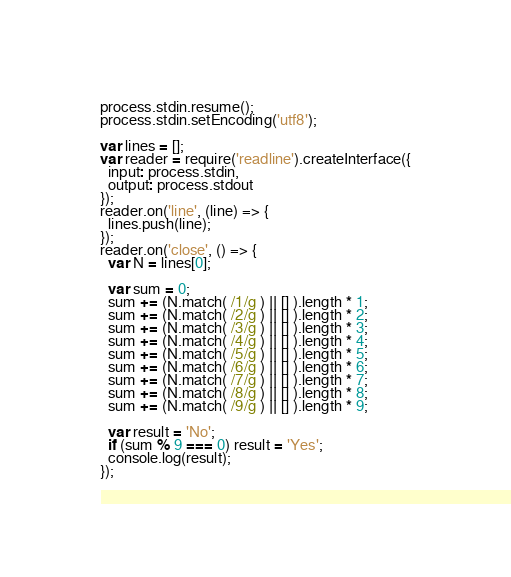<code> <loc_0><loc_0><loc_500><loc_500><_JavaScript_>process.stdin.resume();
process.stdin.setEncoding('utf8');

var lines = [];
var reader = require('readline').createInterface({
  input: process.stdin,
  output: process.stdout
});
reader.on('line', (line) => {
  lines.push(line);
});
reader.on('close', () => {
  var N = lines[0];

  var sum = 0;
  sum += (N.match( /1/g ) || [] ).length * 1;
  sum += (N.match( /2/g ) || [] ).length * 2;
  sum += (N.match( /3/g ) || [] ).length * 3;
  sum += (N.match( /4/g ) || [] ).length * 4;
  sum += (N.match( /5/g ) || [] ).length * 5;
  sum += (N.match( /6/g ) || [] ).length * 6;
  sum += (N.match( /7/g ) || [] ).length * 7;
  sum += (N.match( /8/g ) || [] ).length * 8;
  sum += (N.match( /9/g ) || [] ).length * 9;
  
  var result = 'No';
  if (sum % 9 === 0) result = 'Yes';
  console.log(result);
});</code> 